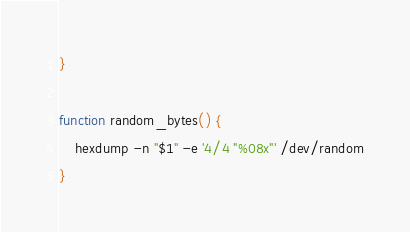Convert code to text. <code><loc_0><loc_0><loc_500><loc_500><_Bash_>}

function random_bytes() {
    hexdump -n "$1" -e '4/4 "%08x"' /dev/random
}
</code> 